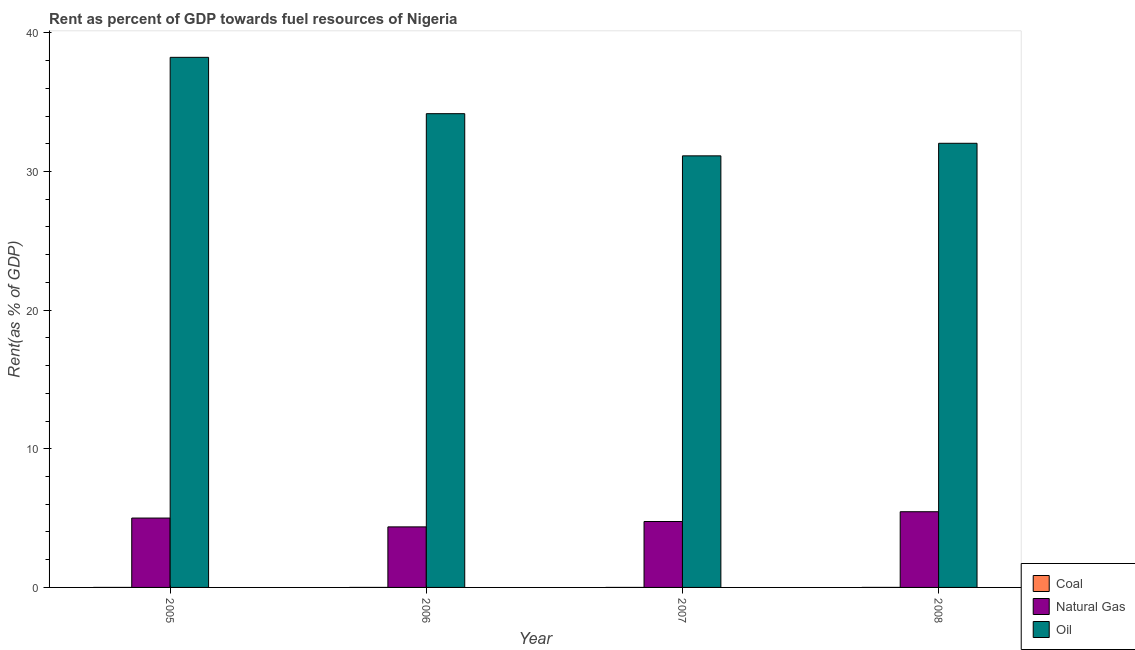How many different coloured bars are there?
Provide a succinct answer. 3. How many groups of bars are there?
Your answer should be compact. 4. Are the number of bars per tick equal to the number of legend labels?
Your answer should be very brief. Yes. Are the number of bars on each tick of the X-axis equal?
Offer a very short reply. Yes. How many bars are there on the 1st tick from the left?
Provide a short and direct response. 3. How many bars are there on the 2nd tick from the right?
Your answer should be compact. 3. What is the label of the 2nd group of bars from the left?
Offer a very short reply. 2006. In how many cases, is the number of bars for a given year not equal to the number of legend labels?
Offer a very short reply. 0. What is the rent towards natural gas in 2007?
Your answer should be compact. 4.75. Across all years, what is the maximum rent towards natural gas?
Your answer should be compact. 5.46. Across all years, what is the minimum rent towards natural gas?
Ensure brevity in your answer.  4.37. What is the total rent towards natural gas in the graph?
Make the answer very short. 19.59. What is the difference between the rent towards natural gas in 2005 and that in 2006?
Offer a terse response. 0.64. What is the difference between the rent towards coal in 2007 and the rent towards oil in 2005?
Your answer should be very brief. 0. What is the average rent towards oil per year?
Keep it short and to the point. 33.9. In how many years, is the rent towards coal greater than 6 %?
Keep it short and to the point. 0. What is the ratio of the rent towards natural gas in 2005 to that in 2007?
Your response must be concise. 1.05. Is the difference between the rent towards natural gas in 2006 and 2008 greater than the difference between the rent towards coal in 2006 and 2008?
Your response must be concise. No. What is the difference between the highest and the second highest rent towards coal?
Provide a succinct answer. 0. What is the difference between the highest and the lowest rent towards coal?
Your answer should be compact. 0. In how many years, is the rent towards coal greater than the average rent towards coal taken over all years?
Your answer should be very brief. 1. Is the sum of the rent towards coal in 2005 and 2006 greater than the maximum rent towards oil across all years?
Give a very brief answer. No. What does the 1st bar from the left in 2007 represents?
Your answer should be very brief. Coal. What does the 1st bar from the right in 2006 represents?
Keep it short and to the point. Oil. Is it the case that in every year, the sum of the rent towards coal and rent towards natural gas is greater than the rent towards oil?
Your answer should be compact. No. How many bars are there?
Offer a very short reply. 12. Are all the bars in the graph horizontal?
Give a very brief answer. No. How many years are there in the graph?
Your response must be concise. 4. Are the values on the major ticks of Y-axis written in scientific E-notation?
Your response must be concise. No. Does the graph contain grids?
Offer a terse response. No. How many legend labels are there?
Provide a succinct answer. 3. What is the title of the graph?
Offer a terse response. Rent as percent of GDP towards fuel resources of Nigeria. What is the label or title of the Y-axis?
Provide a succinct answer. Rent(as % of GDP). What is the Rent(as % of GDP) of Coal in 2005?
Give a very brief answer. 7.12144815130343e-5. What is the Rent(as % of GDP) in Natural Gas in 2005?
Your answer should be very brief. 5. What is the Rent(as % of GDP) in Oil in 2005?
Provide a short and direct response. 38.24. What is the Rent(as % of GDP) in Coal in 2006?
Your answer should be very brief. 6.556049713101229e-5. What is the Rent(as % of GDP) of Natural Gas in 2006?
Provide a short and direct response. 4.37. What is the Rent(as % of GDP) in Oil in 2006?
Provide a succinct answer. 34.17. What is the Rent(as % of GDP) of Coal in 2007?
Keep it short and to the point. 0. What is the Rent(as % of GDP) of Natural Gas in 2007?
Provide a succinct answer. 4.75. What is the Rent(as % of GDP) of Oil in 2007?
Your response must be concise. 31.13. What is the Rent(as % of GDP) in Coal in 2008?
Make the answer very short. 0. What is the Rent(as % of GDP) in Natural Gas in 2008?
Give a very brief answer. 5.46. What is the Rent(as % of GDP) of Oil in 2008?
Ensure brevity in your answer.  32.04. Across all years, what is the maximum Rent(as % of GDP) in Coal?
Make the answer very short. 0. Across all years, what is the maximum Rent(as % of GDP) of Natural Gas?
Provide a succinct answer. 5.46. Across all years, what is the maximum Rent(as % of GDP) in Oil?
Your answer should be very brief. 38.24. Across all years, what is the minimum Rent(as % of GDP) in Coal?
Provide a short and direct response. 6.556049713101229e-5. Across all years, what is the minimum Rent(as % of GDP) in Natural Gas?
Make the answer very short. 4.37. Across all years, what is the minimum Rent(as % of GDP) in Oil?
Provide a short and direct response. 31.13. What is the total Rent(as % of GDP) of Coal in the graph?
Make the answer very short. 0. What is the total Rent(as % of GDP) of Natural Gas in the graph?
Give a very brief answer. 19.59. What is the total Rent(as % of GDP) of Oil in the graph?
Make the answer very short. 135.58. What is the difference between the Rent(as % of GDP) in Natural Gas in 2005 and that in 2006?
Provide a succinct answer. 0.64. What is the difference between the Rent(as % of GDP) in Oil in 2005 and that in 2006?
Offer a terse response. 4.07. What is the difference between the Rent(as % of GDP) of Coal in 2005 and that in 2007?
Ensure brevity in your answer.  -0. What is the difference between the Rent(as % of GDP) in Natural Gas in 2005 and that in 2007?
Give a very brief answer. 0.25. What is the difference between the Rent(as % of GDP) in Oil in 2005 and that in 2007?
Provide a succinct answer. 7.11. What is the difference between the Rent(as % of GDP) in Coal in 2005 and that in 2008?
Offer a very short reply. -0. What is the difference between the Rent(as % of GDP) in Natural Gas in 2005 and that in 2008?
Provide a succinct answer. -0.46. What is the difference between the Rent(as % of GDP) of Oil in 2005 and that in 2008?
Ensure brevity in your answer.  6.2. What is the difference between the Rent(as % of GDP) of Coal in 2006 and that in 2007?
Your answer should be very brief. -0. What is the difference between the Rent(as % of GDP) in Natural Gas in 2006 and that in 2007?
Give a very brief answer. -0.39. What is the difference between the Rent(as % of GDP) of Oil in 2006 and that in 2007?
Provide a succinct answer. 3.04. What is the difference between the Rent(as % of GDP) of Coal in 2006 and that in 2008?
Make the answer very short. -0. What is the difference between the Rent(as % of GDP) of Natural Gas in 2006 and that in 2008?
Give a very brief answer. -1.09. What is the difference between the Rent(as % of GDP) in Oil in 2006 and that in 2008?
Offer a very short reply. 2.14. What is the difference between the Rent(as % of GDP) of Coal in 2007 and that in 2008?
Offer a very short reply. -0. What is the difference between the Rent(as % of GDP) in Natural Gas in 2007 and that in 2008?
Your answer should be compact. -0.71. What is the difference between the Rent(as % of GDP) in Oil in 2007 and that in 2008?
Keep it short and to the point. -0.91. What is the difference between the Rent(as % of GDP) in Coal in 2005 and the Rent(as % of GDP) in Natural Gas in 2006?
Offer a terse response. -4.37. What is the difference between the Rent(as % of GDP) in Coal in 2005 and the Rent(as % of GDP) in Oil in 2006?
Offer a very short reply. -34.17. What is the difference between the Rent(as % of GDP) in Natural Gas in 2005 and the Rent(as % of GDP) in Oil in 2006?
Offer a terse response. -29.17. What is the difference between the Rent(as % of GDP) of Coal in 2005 and the Rent(as % of GDP) of Natural Gas in 2007?
Your answer should be compact. -4.75. What is the difference between the Rent(as % of GDP) in Coal in 2005 and the Rent(as % of GDP) in Oil in 2007?
Make the answer very short. -31.13. What is the difference between the Rent(as % of GDP) in Natural Gas in 2005 and the Rent(as % of GDP) in Oil in 2007?
Keep it short and to the point. -26.13. What is the difference between the Rent(as % of GDP) of Coal in 2005 and the Rent(as % of GDP) of Natural Gas in 2008?
Provide a succinct answer. -5.46. What is the difference between the Rent(as % of GDP) in Coal in 2005 and the Rent(as % of GDP) in Oil in 2008?
Your response must be concise. -32.04. What is the difference between the Rent(as % of GDP) in Natural Gas in 2005 and the Rent(as % of GDP) in Oil in 2008?
Ensure brevity in your answer.  -27.03. What is the difference between the Rent(as % of GDP) in Coal in 2006 and the Rent(as % of GDP) in Natural Gas in 2007?
Provide a succinct answer. -4.75. What is the difference between the Rent(as % of GDP) of Coal in 2006 and the Rent(as % of GDP) of Oil in 2007?
Keep it short and to the point. -31.13. What is the difference between the Rent(as % of GDP) of Natural Gas in 2006 and the Rent(as % of GDP) of Oil in 2007?
Offer a terse response. -26.76. What is the difference between the Rent(as % of GDP) of Coal in 2006 and the Rent(as % of GDP) of Natural Gas in 2008?
Offer a terse response. -5.46. What is the difference between the Rent(as % of GDP) in Coal in 2006 and the Rent(as % of GDP) in Oil in 2008?
Provide a short and direct response. -32.04. What is the difference between the Rent(as % of GDP) of Natural Gas in 2006 and the Rent(as % of GDP) of Oil in 2008?
Provide a short and direct response. -27.67. What is the difference between the Rent(as % of GDP) in Coal in 2007 and the Rent(as % of GDP) in Natural Gas in 2008?
Ensure brevity in your answer.  -5.46. What is the difference between the Rent(as % of GDP) of Coal in 2007 and the Rent(as % of GDP) of Oil in 2008?
Provide a succinct answer. -32.04. What is the difference between the Rent(as % of GDP) in Natural Gas in 2007 and the Rent(as % of GDP) in Oil in 2008?
Keep it short and to the point. -27.28. What is the average Rent(as % of GDP) in Natural Gas per year?
Make the answer very short. 4.9. What is the average Rent(as % of GDP) of Oil per year?
Provide a succinct answer. 33.9. In the year 2005, what is the difference between the Rent(as % of GDP) of Coal and Rent(as % of GDP) of Natural Gas?
Provide a succinct answer. -5. In the year 2005, what is the difference between the Rent(as % of GDP) of Coal and Rent(as % of GDP) of Oil?
Make the answer very short. -38.24. In the year 2005, what is the difference between the Rent(as % of GDP) of Natural Gas and Rent(as % of GDP) of Oil?
Your response must be concise. -33.23. In the year 2006, what is the difference between the Rent(as % of GDP) in Coal and Rent(as % of GDP) in Natural Gas?
Make the answer very short. -4.37. In the year 2006, what is the difference between the Rent(as % of GDP) of Coal and Rent(as % of GDP) of Oil?
Offer a very short reply. -34.17. In the year 2006, what is the difference between the Rent(as % of GDP) in Natural Gas and Rent(as % of GDP) in Oil?
Give a very brief answer. -29.81. In the year 2007, what is the difference between the Rent(as % of GDP) in Coal and Rent(as % of GDP) in Natural Gas?
Keep it short and to the point. -4.75. In the year 2007, what is the difference between the Rent(as % of GDP) of Coal and Rent(as % of GDP) of Oil?
Make the answer very short. -31.13. In the year 2007, what is the difference between the Rent(as % of GDP) in Natural Gas and Rent(as % of GDP) in Oil?
Offer a terse response. -26.38. In the year 2008, what is the difference between the Rent(as % of GDP) in Coal and Rent(as % of GDP) in Natural Gas?
Offer a terse response. -5.46. In the year 2008, what is the difference between the Rent(as % of GDP) in Coal and Rent(as % of GDP) in Oil?
Your answer should be compact. -32.04. In the year 2008, what is the difference between the Rent(as % of GDP) of Natural Gas and Rent(as % of GDP) of Oil?
Keep it short and to the point. -26.58. What is the ratio of the Rent(as % of GDP) of Coal in 2005 to that in 2006?
Give a very brief answer. 1.09. What is the ratio of the Rent(as % of GDP) in Natural Gas in 2005 to that in 2006?
Offer a very short reply. 1.15. What is the ratio of the Rent(as % of GDP) in Oil in 2005 to that in 2006?
Make the answer very short. 1.12. What is the ratio of the Rent(as % of GDP) of Coal in 2005 to that in 2007?
Give a very brief answer. 0.23. What is the ratio of the Rent(as % of GDP) in Natural Gas in 2005 to that in 2007?
Offer a terse response. 1.05. What is the ratio of the Rent(as % of GDP) in Oil in 2005 to that in 2007?
Make the answer very short. 1.23. What is the ratio of the Rent(as % of GDP) of Coal in 2005 to that in 2008?
Your answer should be very brief. 0.06. What is the ratio of the Rent(as % of GDP) in Natural Gas in 2005 to that in 2008?
Make the answer very short. 0.92. What is the ratio of the Rent(as % of GDP) of Oil in 2005 to that in 2008?
Provide a succinct answer. 1.19. What is the ratio of the Rent(as % of GDP) of Coal in 2006 to that in 2007?
Your answer should be very brief. 0.21. What is the ratio of the Rent(as % of GDP) of Natural Gas in 2006 to that in 2007?
Keep it short and to the point. 0.92. What is the ratio of the Rent(as % of GDP) of Oil in 2006 to that in 2007?
Provide a succinct answer. 1.1. What is the ratio of the Rent(as % of GDP) in Coal in 2006 to that in 2008?
Provide a succinct answer. 0.05. What is the ratio of the Rent(as % of GDP) of Natural Gas in 2006 to that in 2008?
Offer a very short reply. 0.8. What is the ratio of the Rent(as % of GDP) in Oil in 2006 to that in 2008?
Provide a short and direct response. 1.07. What is the ratio of the Rent(as % of GDP) in Coal in 2007 to that in 2008?
Provide a short and direct response. 0.26. What is the ratio of the Rent(as % of GDP) in Natural Gas in 2007 to that in 2008?
Ensure brevity in your answer.  0.87. What is the ratio of the Rent(as % of GDP) of Oil in 2007 to that in 2008?
Make the answer very short. 0.97. What is the difference between the highest and the second highest Rent(as % of GDP) of Coal?
Keep it short and to the point. 0. What is the difference between the highest and the second highest Rent(as % of GDP) in Natural Gas?
Ensure brevity in your answer.  0.46. What is the difference between the highest and the second highest Rent(as % of GDP) in Oil?
Ensure brevity in your answer.  4.07. What is the difference between the highest and the lowest Rent(as % of GDP) of Coal?
Your answer should be very brief. 0. What is the difference between the highest and the lowest Rent(as % of GDP) in Natural Gas?
Give a very brief answer. 1.09. What is the difference between the highest and the lowest Rent(as % of GDP) of Oil?
Offer a terse response. 7.11. 